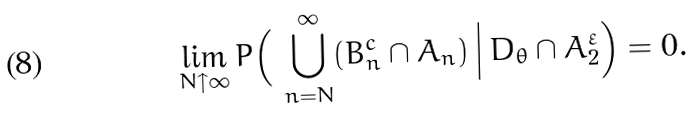<formula> <loc_0><loc_0><loc_500><loc_500>\lim _ { N \uparrow \infty } P \Big ( \, \bigcup _ { n = N } ^ { \infty } ( B _ { n } ^ { c } \cap A _ { n } ) \, \Big | \, D _ { \theta } \cap A _ { 2 } ^ { \varepsilon } \Big ) = 0 .</formula> 